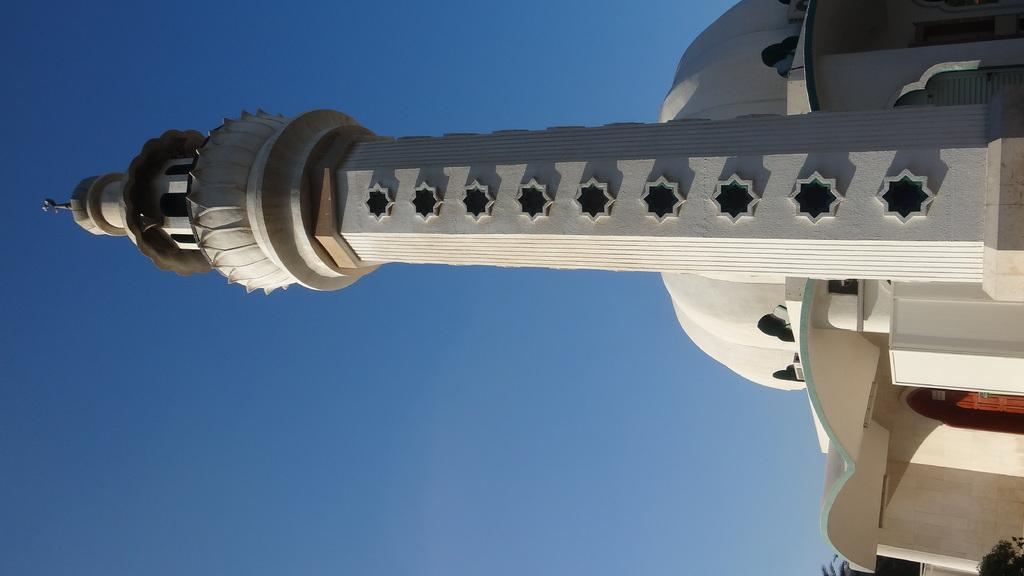What type of construction is taking place in the image? There is building construction in the image. Can you describe a specific feature of the building being constructed? There is a dome construction at the top of the building. What can be seen in the background of the image? The sky is visible in the image. What type of texture can be seen on the floor in the image? There is no floor visible in the image, as it focuses on the building construction. 